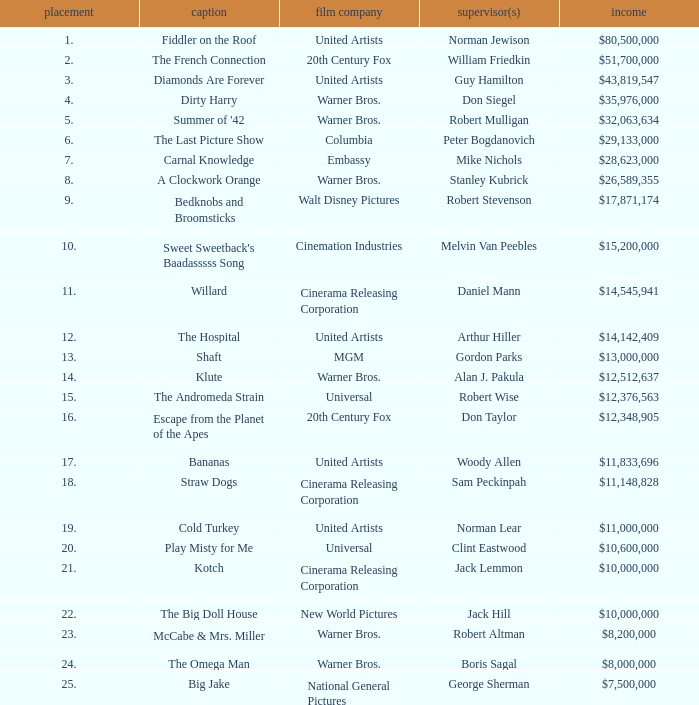Which title with a rank under 19 has a total income of $11,833,696? Bananas. 